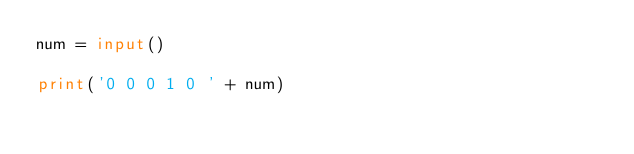<code> <loc_0><loc_0><loc_500><loc_500><_Python_>num = input()

print('0 0 0 1 0 ' + num)
</code> 